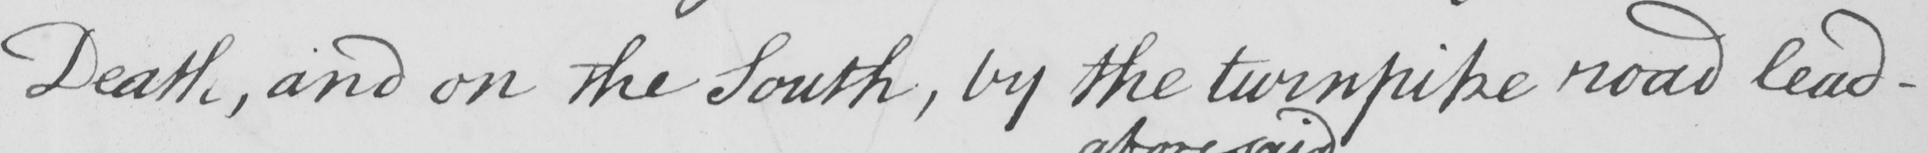Please transcribe the handwritten text in this image. Death , and on the South , by the turnpike road lead- 